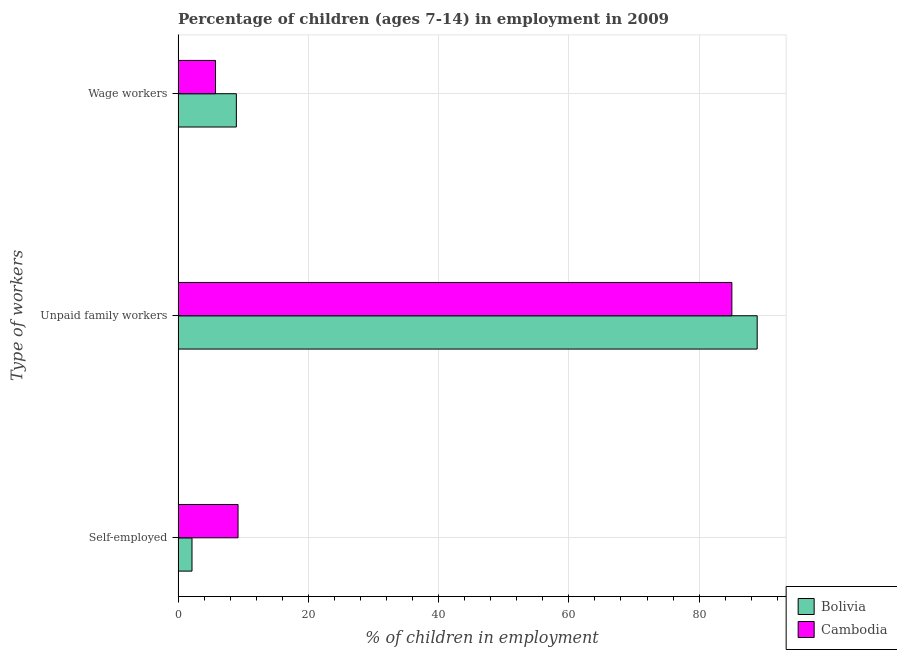How many groups of bars are there?
Offer a very short reply. 3. Are the number of bars on each tick of the Y-axis equal?
Make the answer very short. Yes. How many bars are there on the 3rd tick from the top?
Your answer should be compact. 2. How many bars are there on the 1st tick from the bottom?
Your answer should be very brief. 2. What is the label of the 3rd group of bars from the top?
Keep it short and to the point. Self-employed. What is the percentage of children employed as unpaid family workers in Cambodia?
Give a very brief answer. 85.02. Across all countries, what is the maximum percentage of children employed as unpaid family workers?
Offer a terse response. 88.91. Across all countries, what is the minimum percentage of self employed children?
Keep it short and to the point. 2.14. In which country was the percentage of self employed children minimum?
Offer a terse response. Bolivia. What is the total percentage of children employed as wage workers in the graph?
Your answer should be compact. 14.7. What is the difference between the percentage of children employed as wage workers in Bolivia and that in Cambodia?
Your answer should be very brief. 3.2. What is the difference between the percentage of children employed as unpaid family workers in Bolivia and the percentage of self employed children in Cambodia?
Your answer should be very brief. 79.7. What is the average percentage of self employed children per country?
Ensure brevity in your answer.  5.68. What is the difference between the percentage of self employed children and percentage of children employed as unpaid family workers in Bolivia?
Provide a short and direct response. -86.77. What is the ratio of the percentage of self employed children in Cambodia to that in Bolivia?
Provide a short and direct response. 4.3. Is the percentage of children employed as wage workers in Bolivia less than that in Cambodia?
Keep it short and to the point. No. What is the difference between the highest and the second highest percentage of children employed as wage workers?
Your answer should be very brief. 3.2. What is the difference between the highest and the lowest percentage of children employed as unpaid family workers?
Provide a succinct answer. 3.89. In how many countries, is the percentage of self employed children greater than the average percentage of self employed children taken over all countries?
Keep it short and to the point. 1. What does the 1st bar from the bottom in Unpaid family workers represents?
Ensure brevity in your answer.  Bolivia. Is it the case that in every country, the sum of the percentage of self employed children and percentage of children employed as unpaid family workers is greater than the percentage of children employed as wage workers?
Provide a succinct answer. Yes. Are all the bars in the graph horizontal?
Give a very brief answer. Yes. How many countries are there in the graph?
Make the answer very short. 2. What is the difference between two consecutive major ticks on the X-axis?
Provide a short and direct response. 20. Are the values on the major ticks of X-axis written in scientific E-notation?
Your answer should be very brief. No. Does the graph contain grids?
Ensure brevity in your answer.  Yes. What is the title of the graph?
Make the answer very short. Percentage of children (ages 7-14) in employment in 2009. What is the label or title of the X-axis?
Provide a succinct answer. % of children in employment. What is the label or title of the Y-axis?
Your answer should be compact. Type of workers. What is the % of children in employment of Bolivia in Self-employed?
Provide a succinct answer. 2.14. What is the % of children in employment of Cambodia in Self-employed?
Provide a short and direct response. 9.21. What is the % of children in employment in Bolivia in Unpaid family workers?
Provide a succinct answer. 88.91. What is the % of children in employment of Cambodia in Unpaid family workers?
Provide a succinct answer. 85.02. What is the % of children in employment of Bolivia in Wage workers?
Ensure brevity in your answer.  8.95. What is the % of children in employment in Cambodia in Wage workers?
Offer a terse response. 5.75. Across all Type of workers, what is the maximum % of children in employment of Bolivia?
Provide a succinct answer. 88.91. Across all Type of workers, what is the maximum % of children in employment of Cambodia?
Your answer should be compact. 85.02. Across all Type of workers, what is the minimum % of children in employment in Bolivia?
Keep it short and to the point. 2.14. Across all Type of workers, what is the minimum % of children in employment in Cambodia?
Make the answer very short. 5.75. What is the total % of children in employment in Cambodia in the graph?
Your answer should be very brief. 99.98. What is the difference between the % of children in employment in Bolivia in Self-employed and that in Unpaid family workers?
Provide a short and direct response. -86.77. What is the difference between the % of children in employment in Cambodia in Self-employed and that in Unpaid family workers?
Provide a succinct answer. -75.81. What is the difference between the % of children in employment of Bolivia in Self-employed and that in Wage workers?
Your answer should be compact. -6.81. What is the difference between the % of children in employment in Cambodia in Self-employed and that in Wage workers?
Your response must be concise. 3.46. What is the difference between the % of children in employment in Bolivia in Unpaid family workers and that in Wage workers?
Provide a succinct answer. 79.96. What is the difference between the % of children in employment in Cambodia in Unpaid family workers and that in Wage workers?
Give a very brief answer. 79.27. What is the difference between the % of children in employment in Bolivia in Self-employed and the % of children in employment in Cambodia in Unpaid family workers?
Ensure brevity in your answer.  -82.88. What is the difference between the % of children in employment of Bolivia in Self-employed and the % of children in employment of Cambodia in Wage workers?
Ensure brevity in your answer.  -3.61. What is the difference between the % of children in employment in Bolivia in Unpaid family workers and the % of children in employment in Cambodia in Wage workers?
Give a very brief answer. 83.16. What is the average % of children in employment in Bolivia per Type of workers?
Your response must be concise. 33.33. What is the average % of children in employment of Cambodia per Type of workers?
Keep it short and to the point. 33.33. What is the difference between the % of children in employment of Bolivia and % of children in employment of Cambodia in Self-employed?
Provide a short and direct response. -7.07. What is the difference between the % of children in employment in Bolivia and % of children in employment in Cambodia in Unpaid family workers?
Your answer should be very brief. 3.89. What is the difference between the % of children in employment of Bolivia and % of children in employment of Cambodia in Wage workers?
Make the answer very short. 3.2. What is the ratio of the % of children in employment in Bolivia in Self-employed to that in Unpaid family workers?
Keep it short and to the point. 0.02. What is the ratio of the % of children in employment of Cambodia in Self-employed to that in Unpaid family workers?
Make the answer very short. 0.11. What is the ratio of the % of children in employment of Bolivia in Self-employed to that in Wage workers?
Give a very brief answer. 0.24. What is the ratio of the % of children in employment in Cambodia in Self-employed to that in Wage workers?
Your response must be concise. 1.6. What is the ratio of the % of children in employment in Bolivia in Unpaid family workers to that in Wage workers?
Keep it short and to the point. 9.93. What is the ratio of the % of children in employment of Cambodia in Unpaid family workers to that in Wage workers?
Your answer should be compact. 14.79. What is the difference between the highest and the second highest % of children in employment of Bolivia?
Your answer should be compact. 79.96. What is the difference between the highest and the second highest % of children in employment in Cambodia?
Offer a terse response. 75.81. What is the difference between the highest and the lowest % of children in employment in Bolivia?
Your answer should be compact. 86.77. What is the difference between the highest and the lowest % of children in employment of Cambodia?
Give a very brief answer. 79.27. 